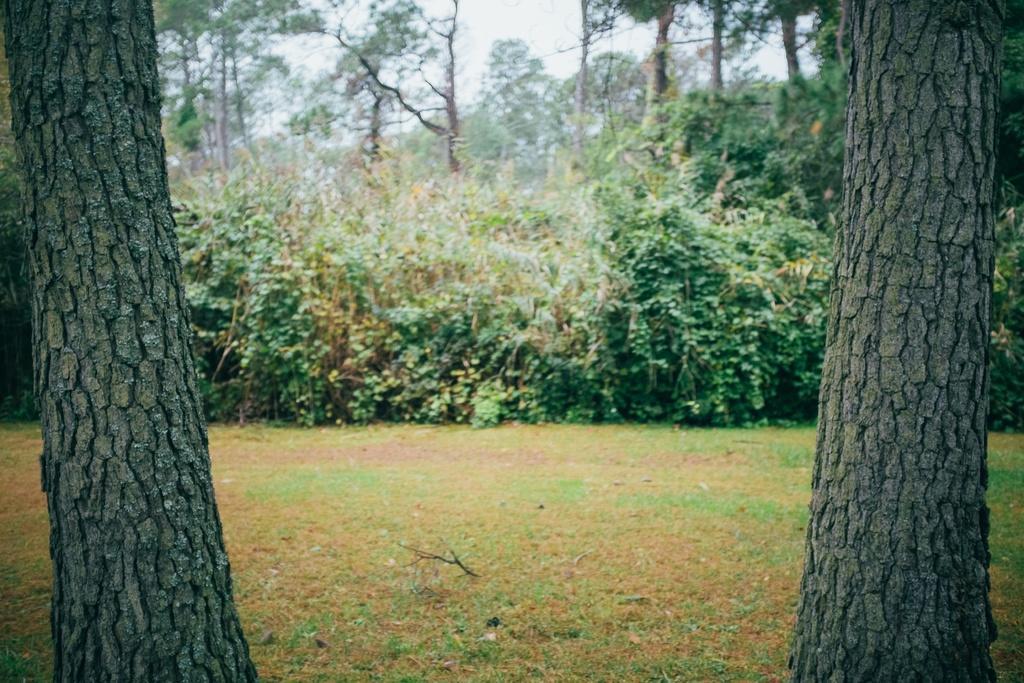Please provide a concise description of this image. In this image there are trees and grass on the surface. 